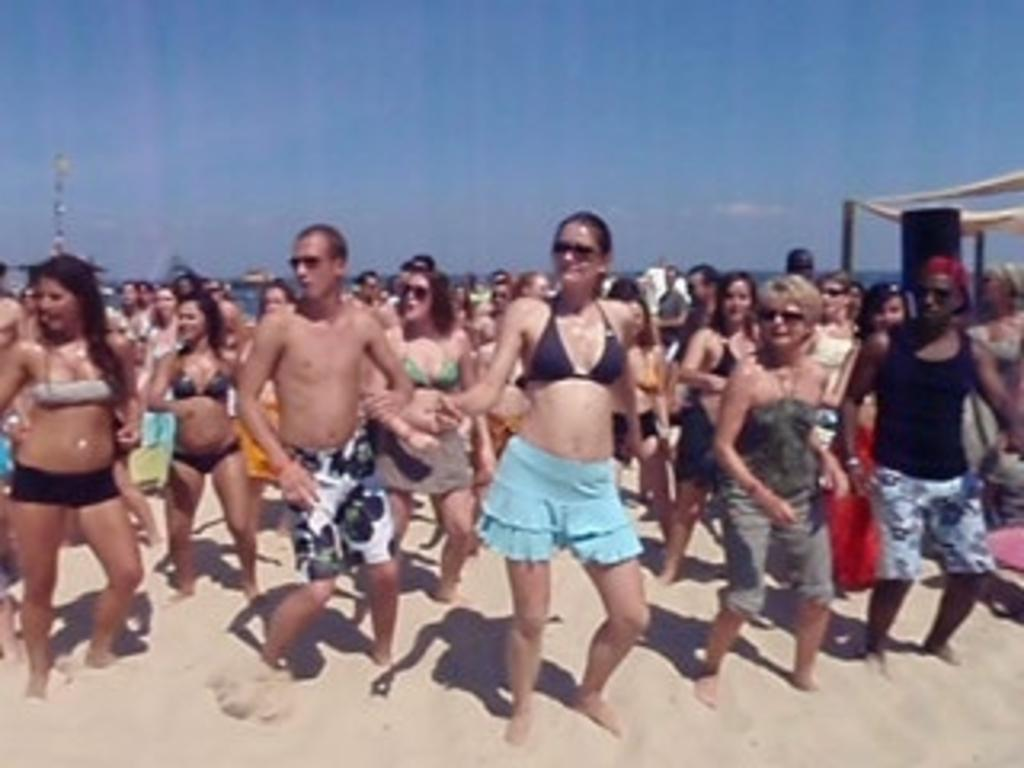What types of people are in the image? There are men and women in the image. Where are the people located in the image? They are standing on the seashore. What can be seen in the background of the image? There is a sea, a tower, and the sky visible in the background of the image. What type of coil is being used by the spy in the image? There is no coil or spy present in the image; it features men and women standing on the seashore with a sea, a tower, and the sky visible in the background. 